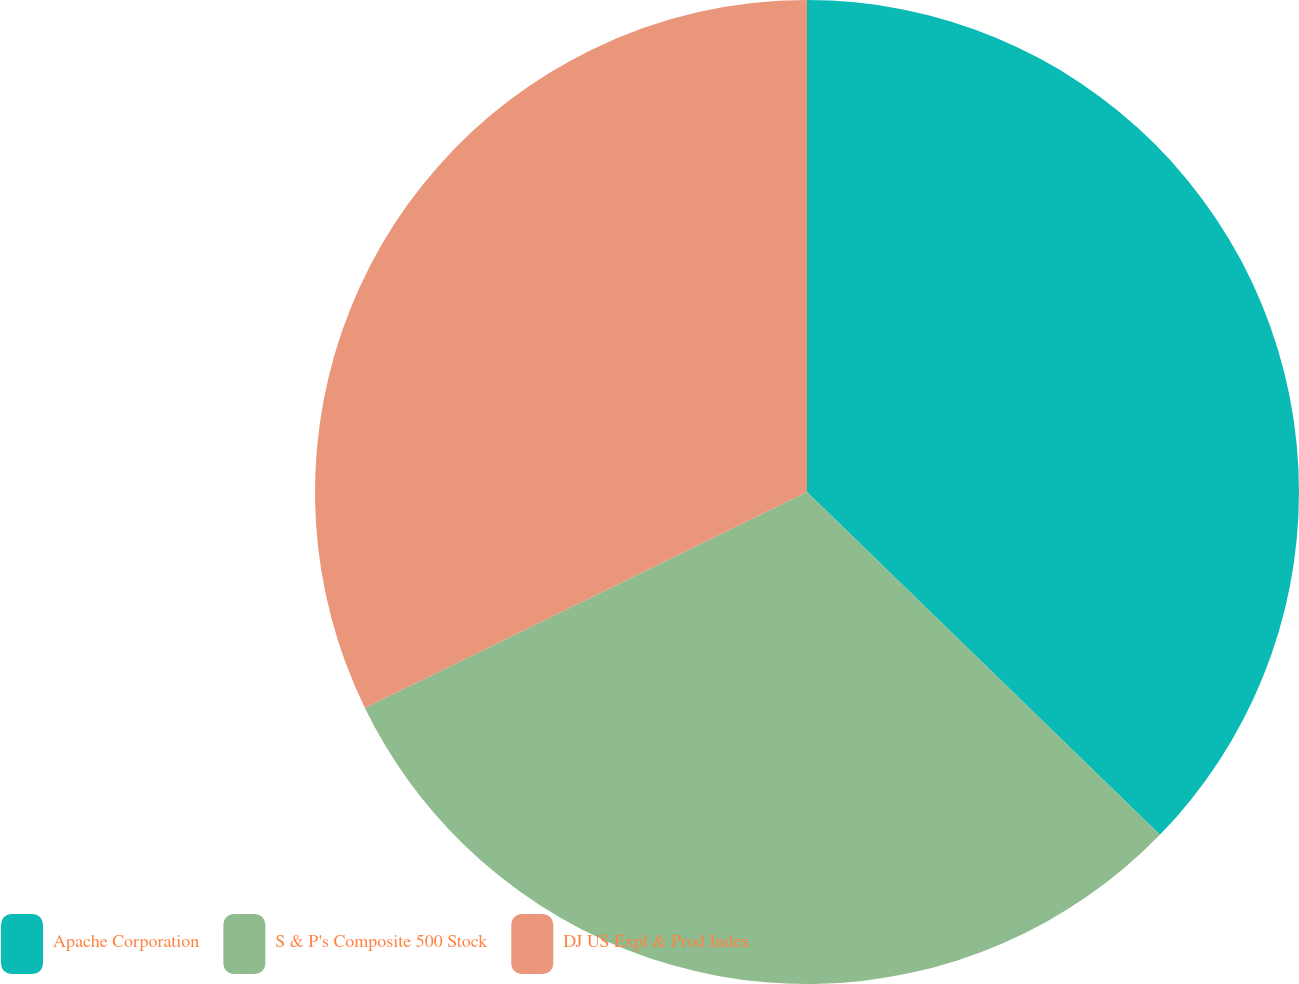Convert chart. <chart><loc_0><loc_0><loc_500><loc_500><pie_chart><fcel>Apache Corporation<fcel>S & P's Composite 500 Stock<fcel>DJ US Expl & Prod Index<nl><fcel>37.27%<fcel>30.5%<fcel>32.23%<nl></chart> 